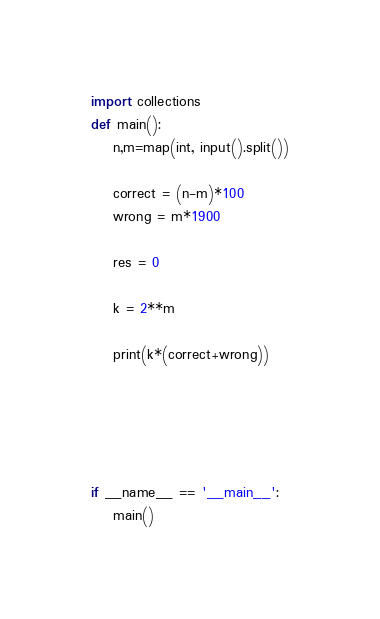Convert code to text. <code><loc_0><loc_0><loc_500><loc_500><_Python_>import collections
def main():
    n,m=map(int, input().split())

    correct = (n-m)*100
    wrong = m*1900

    res = 0

    k = 2**m

    print(k*(correct+wrong))

    



if __name__ == '__main__':
    main()
</code> 